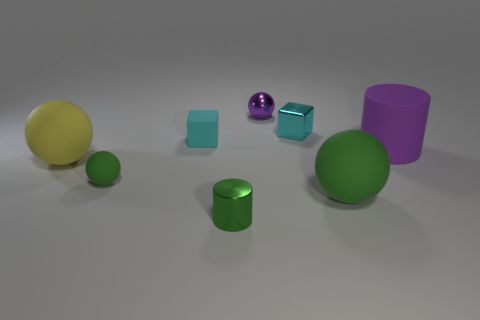Do the purple ball and the cylinder left of the big purple object have the same material?
Provide a succinct answer. Yes. Are there fewer large objects to the right of the cyan shiny thing than tiny cyan rubber things?
Ensure brevity in your answer.  No. How many other objects are there of the same shape as the small green metallic object?
Your answer should be very brief. 1. Is there anything else that is the same color as the shiny cylinder?
Offer a terse response. Yes. Does the big rubber cylinder have the same color as the tiny matte object that is behind the purple rubber cylinder?
Offer a very short reply. No. What number of other things are there of the same size as the purple ball?
Your answer should be compact. 4. There is a cylinder that is the same color as the tiny rubber ball; what size is it?
Provide a succinct answer. Small. What number of balls are either purple metallic objects or large gray metal things?
Your answer should be very brief. 1. There is a green rubber thing that is behind the large green thing; does it have the same shape as the large yellow object?
Give a very brief answer. Yes. Are there more metal cubes behind the purple metallic sphere than big green balls?
Make the answer very short. No. 